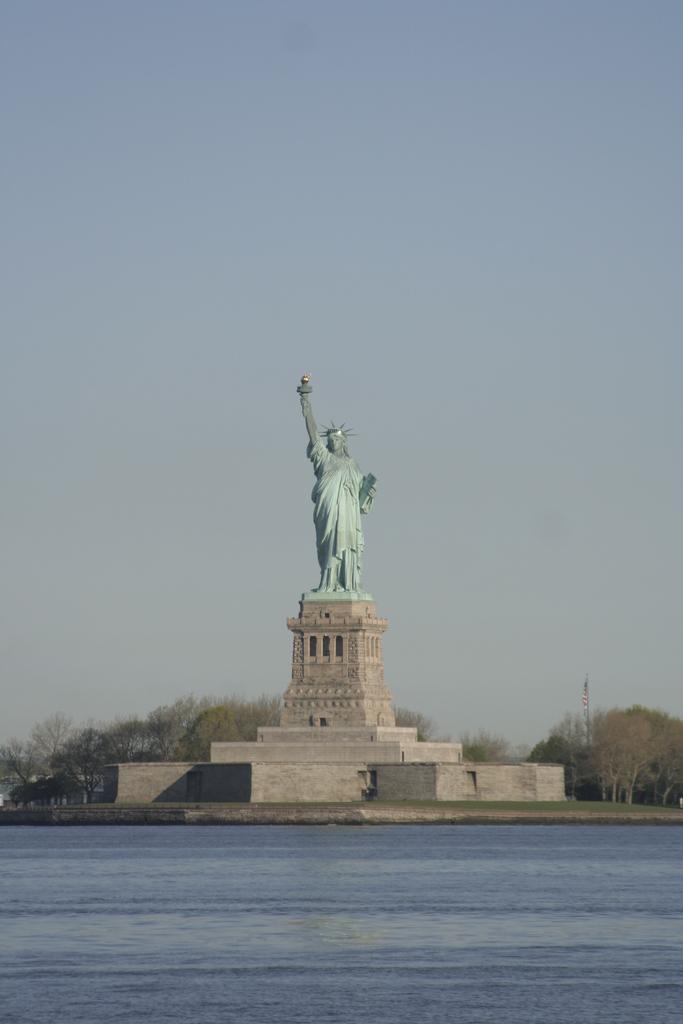In one or two sentences, can you explain what this image depicts? In this image we can see water, grass, trees, and a statue on a pedestal. In the background there is sky. 